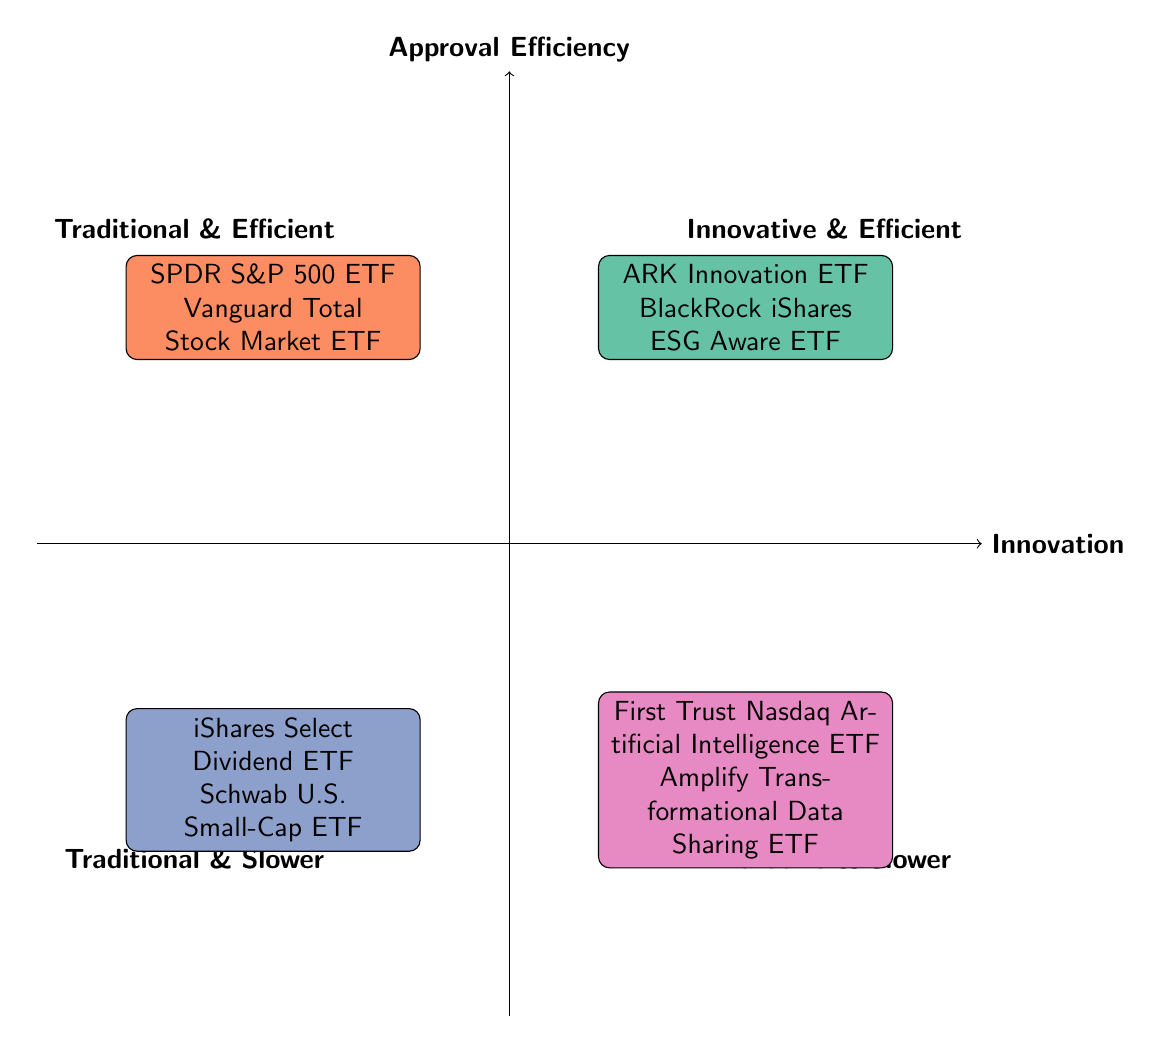What are the two examples in the Innovative & Efficient quadrant? The Innovative & Efficient quadrant identifies two ETFs: ARK Innovation ETF and BlackRock iShares ESG Aware ETF.
Answer: ARK Innovation ETF, BlackRock iShares ESG Aware ETF What does the Traditional & Efficient quadrant represent? The Traditional & Efficient quadrant showcases ETFs that offer broad market exposure with rapid approval processes, exemplified by products like SPDR S&P 500 ETF and Vanguard Total Stock Market ETF.
Answer: Broad market exposure with rapid approval Which quadrant includes ETFs with innovative structures but slower approval timelines? The Innovative & Slower quadrant is where ETFs have innovative structures but face slower approval timelines, such as First Trust Nasdaq Artificial Intelligence ETF and Amplify Transformational Data Sharing ETF.
Answer: Innovative & Slower How many ETFs are listed in the Traditional & Slower quadrant? There are two ETFs listed in the Traditional & Slower quadrant: iShares Select Dividend ETF and Schwab U.S. Small-Cap ETF.
Answer: 2 Which quadrant would you find the SPDR S&P 500 ETF? The SPDR S&P 500 ETF is located in the Traditional & Efficient quadrant, characterized by its broad market exposure and rapid approval process.
Answer: Traditional & Efficient What is a common characteristic of the ETFs in the Innovative & Efficient quadrant? A common characteristic of the ETFs in the Innovative & Efficient quadrant is that they incorporate new investment themes and strategies while maintaining a moderate approval time.
Answer: Moderate approval time How do ETFs in the Traditional & Slower quadrant differ from those in the Innovative & Slower quadrant? ETFs in the Traditional & Slower quadrant focus on established investment strategies and generally have a slower approval process compared to those in the Innovative & Slower quadrant, which focus on newer, untested investment ideas.
Answer: Established strategies vs. newer ideas What is the approval time for the BlackRock iShares ESG Aware ETF? The BlackRock iShares ESG Aware ETF has a moderate approval time.
Answer: Moderate Which quadrant has the ETFs with the longest approval timelines? The Innovative & Slower quadrant contains the ETFs with the longest approval timelines, as they involve novel concepts and require extensive regulatory review.
Answer: Innovative & Slower 